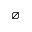Convert formula to latex. <formula><loc_0><loc_0><loc_500><loc_500>\varnothing</formula> 